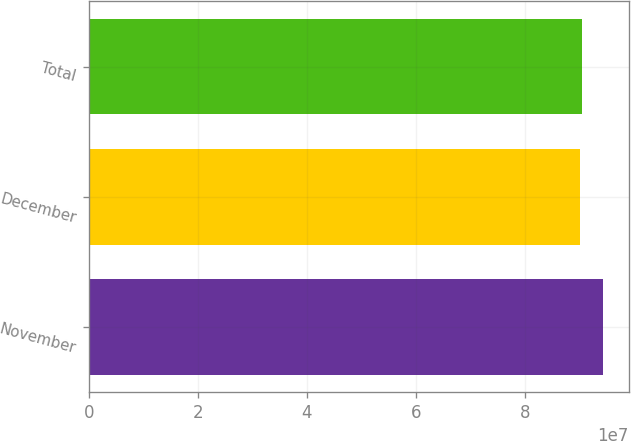<chart> <loc_0><loc_0><loc_500><loc_500><bar_chart><fcel>November<fcel>December<fcel>Total<nl><fcel>9.43967e+07<fcel>9.0202e+07<fcel>9.06215e+07<nl></chart> 